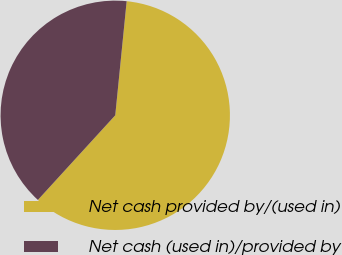Convert chart. <chart><loc_0><loc_0><loc_500><loc_500><pie_chart><fcel>Net cash provided by/(used in)<fcel>Net cash (used in)/provided by<nl><fcel>60.2%<fcel>39.8%<nl></chart> 